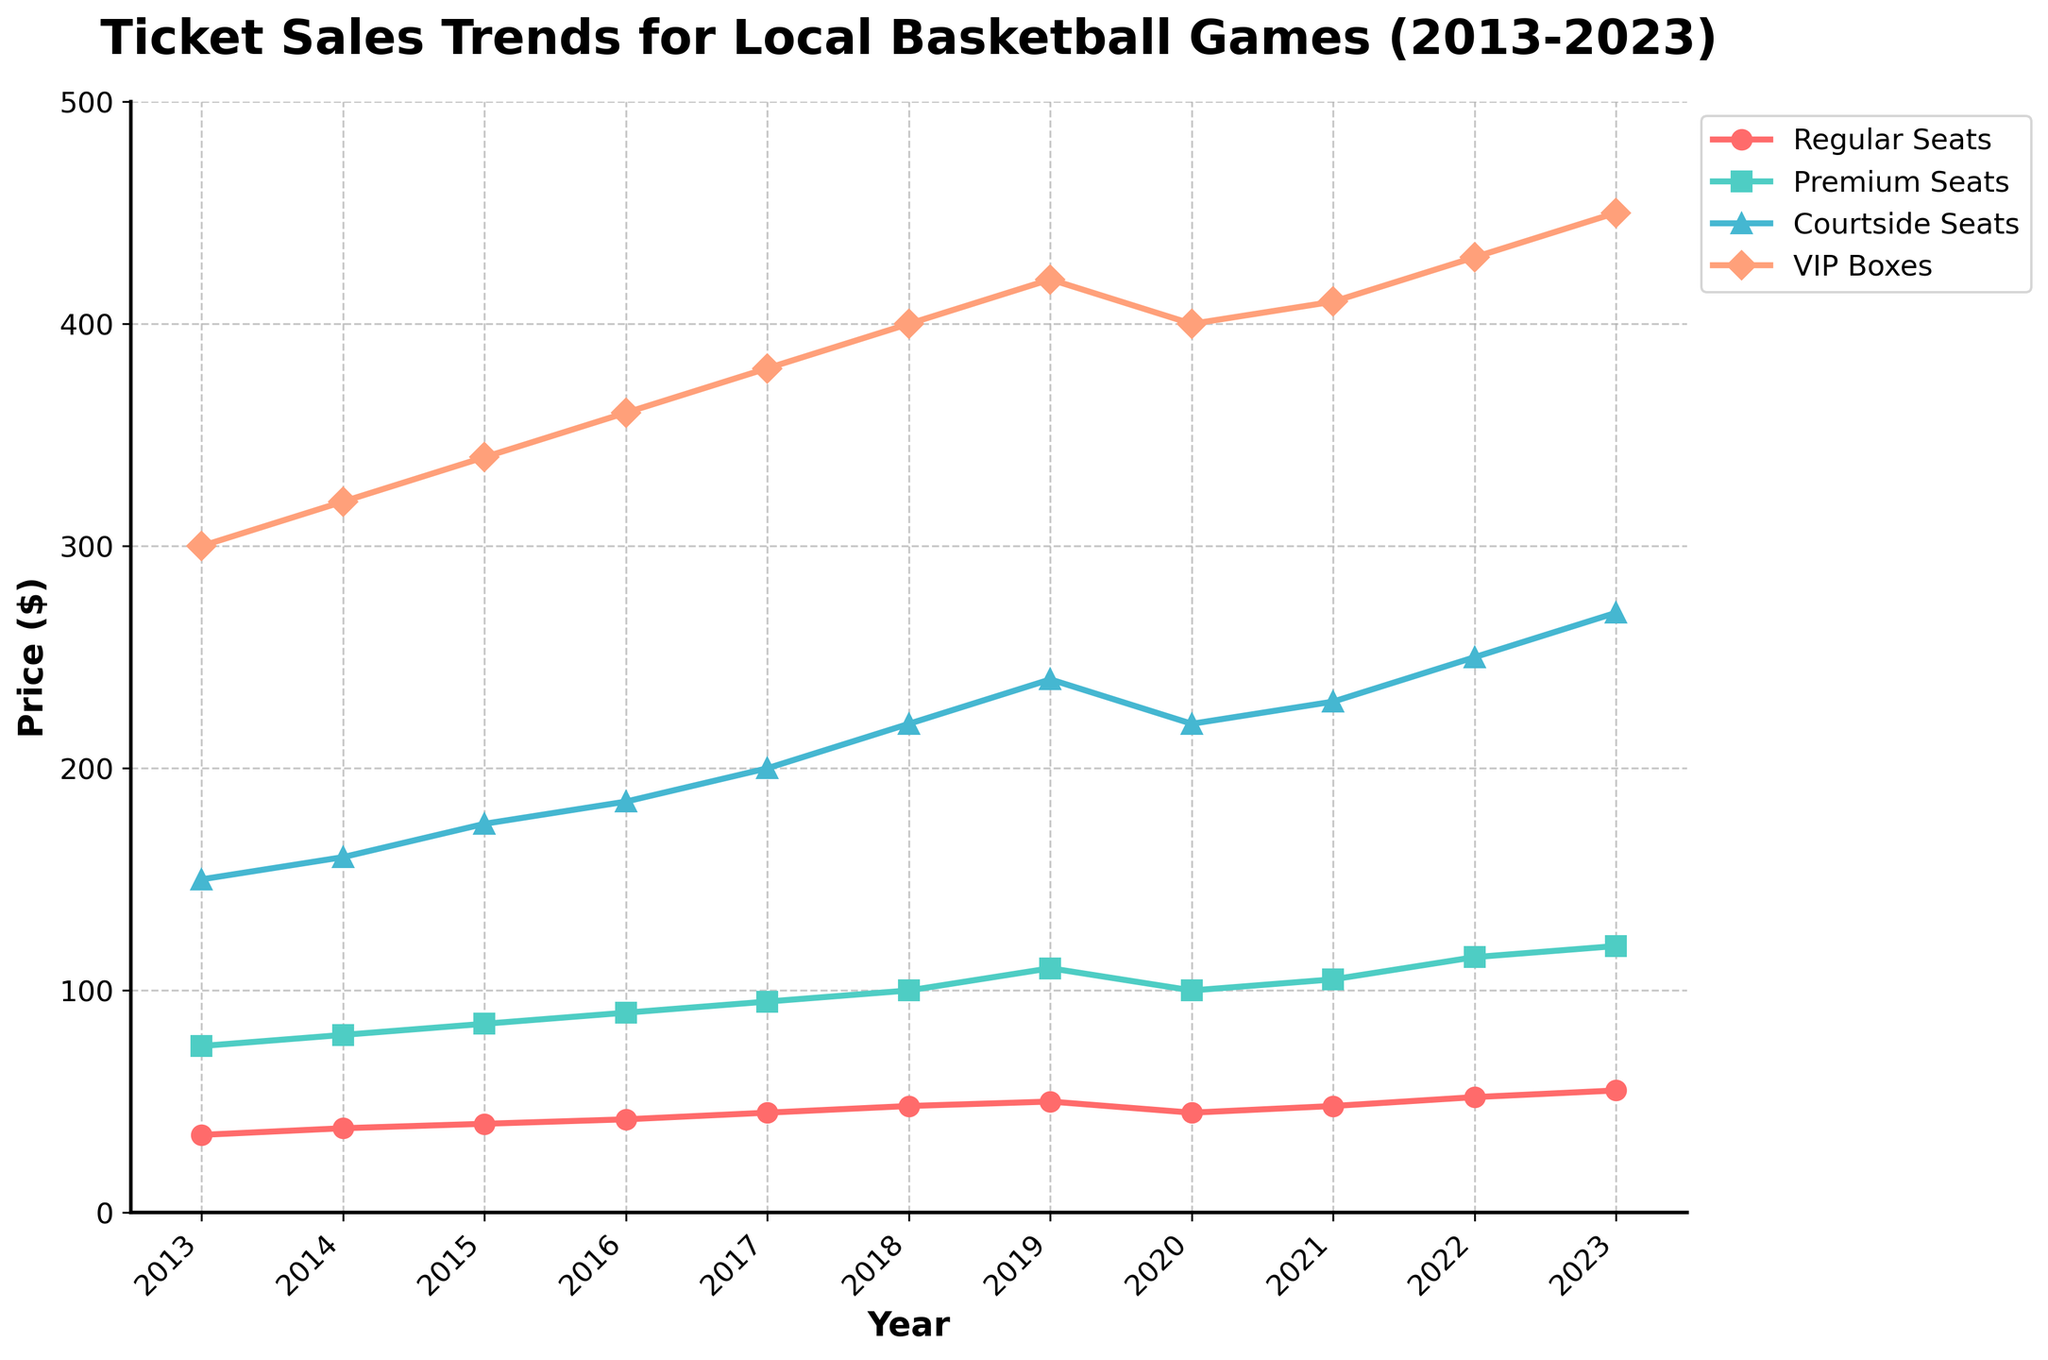Which year saw the highest price for VIP Boxes? The line chart shows that the price for VIP Boxes increased every year except in 2020 where there was a dip. The highest price is labeled at 450 in 2023.
Answer: 2023 Between Premium Seats and Courtside Seats, which one had a higher price in 2019? Looking at the lines for 2019, the Premium Seats are listed at 110, while the Courtside Seats are at 240.
Answer: Courtside Seats What was the price difference between Regular Seats and VIP Boxes in 2018? From the chart, the price of Regular Seats in 2018 is 48 and for VIP Boxes 400. The difference is 400 - 48 = 352.
Answer: 352 Which price tier experienced the most significant drop between 2019 and 2020? From 2019 to 2020, Regular Seats dropped from 50 to 45, Premium Seats from 110 to 100, Courtside Seats from 240 to 220, and VIP Boxes from 420 to 400. The largest drop is for VIP Boxes, which decreased by 20.
Answer: VIP Boxes How many price tiers had a consistent increase in prices from 2013 to 2023 without any drop? Regular Seats, Premium Seats, and Courtside Seats all showed increasing trends without drops. VIP Boxes, however, showed a drop between 2019 and 2020. Therefore, there are three price tiers with consistent increases.
Answer: 3 Which year had a higher price for Regular Seats compared to Premium Seats? At no point does the chart show Regular Seats having a higher price than Premium Seats from 2013 to 2023.
Answer: None What is the average price of Premium Seats over the entire period? The prices for Premium Seats over the years are 75, 80, 85, 90, 95, 100, 110, 100, 105, 115, 120. Summing these prices gives 1075 and dividing by the number of years, 11, we get an average of 97.73.
Answer: 97.73 By how much did the price for Regular Seats increase from 2013 to 2023? The price for Regular Seats in 2013 was 35, and in 2023 it was 55. The increase is 55 - 35 = 20.
Answer: 20 Which year experienced the smallest price increase for Courtside Seats? The smallest increase for Courtside Seats occurs between 2019 and 2020, when the price remained constant at 220, showing no increase.
Answer: 2020 By comparing their trends, which year marked the return to the pre-2020 price levels for all price tiers? Observing the lines, it is clear that all price tiers return to or exceed their 2019 prices by 2022.
Answer: 2022 